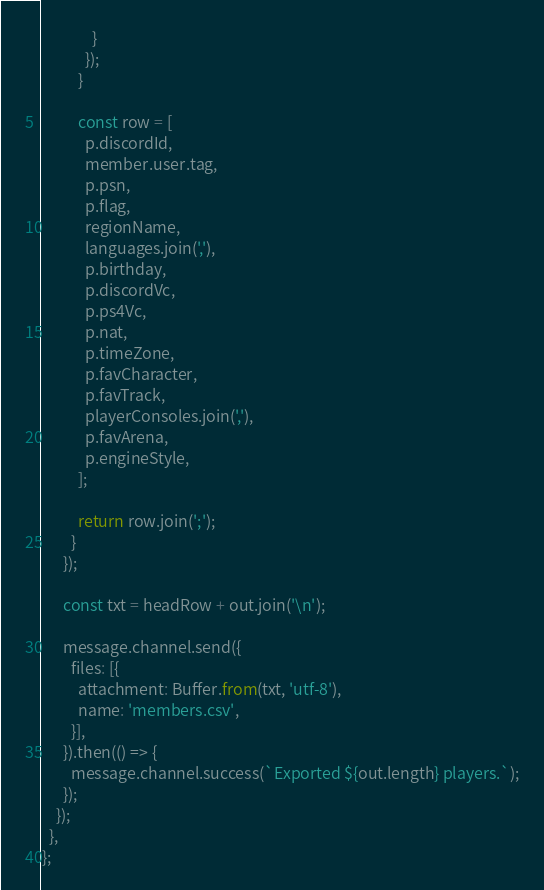<code> <loc_0><loc_0><loc_500><loc_500><_JavaScript_>              }
            });
          }

          const row = [
            p.discordId,
            member.user.tag,
            p.psn,
            p.flag,
            regionName,
            languages.join(','),
            p.birthday,
            p.discordVc,
            p.ps4Vc,
            p.nat,
            p.timeZone,
            p.favCharacter,
            p.favTrack,
            playerConsoles.join(','),
            p.favArena,
            p.engineStyle,
          ];

          return row.join(';');
        }
      });

      const txt = headRow + out.join('\n');

      message.channel.send({
        files: [{
          attachment: Buffer.from(txt, 'utf-8'),
          name: 'members.csv',
        }],
      }).then(() => {
        message.channel.success(`Exported ${out.length} players.`);
      });
    });
  },
};
</code> 